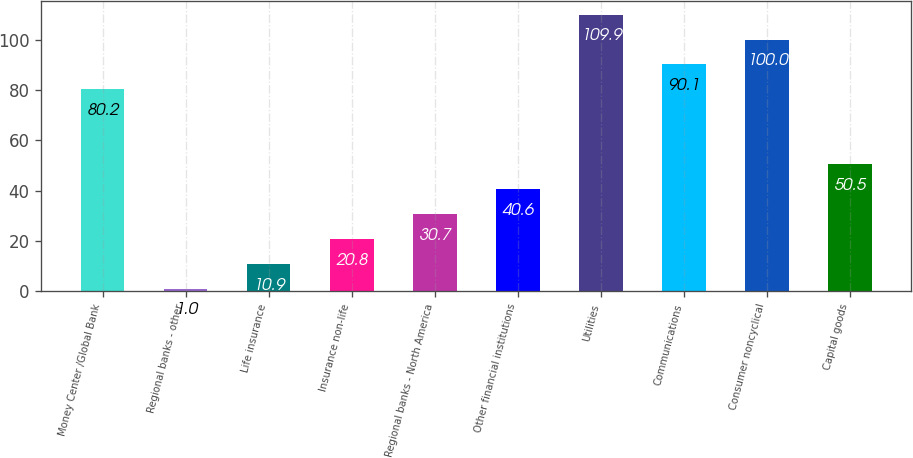Convert chart to OTSL. <chart><loc_0><loc_0><loc_500><loc_500><bar_chart><fcel>Money Center /Global Bank<fcel>Regional banks - other<fcel>Life insurance<fcel>Insurance non-life<fcel>Regional banks - North America<fcel>Other financial institutions<fcel>Utilities<fcel>Communications<fcel>Consumer noncyclical<fcel>Capital goods<nl><fcel>80.2<fcel>1<fcel>10.9<fcel>20.8<fcel>30.7<fcel>40.6<fcel>109.9<fcel>90.1<fcel>100<fcel>50.5<nl></chart> 